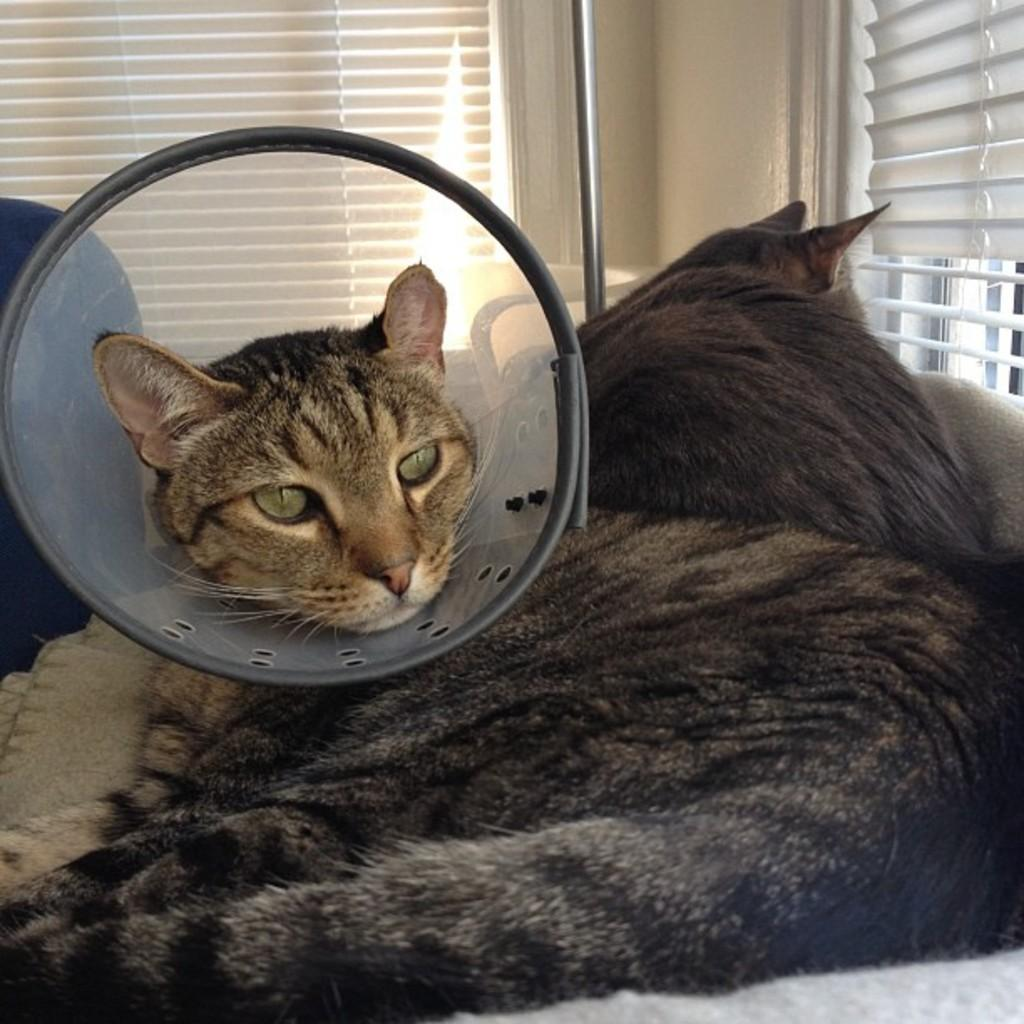What is the cat in the image doing with its head? The cat in the image has its head in an object. Are there any other cats in the image? Yes, there is another cat beside the first cat. What can be seen in the background of the image? There are windows and a rod in the background of the image. What type of substance is flowing through the river in the image? There is no river present in the image; it only features cats and background elements. 